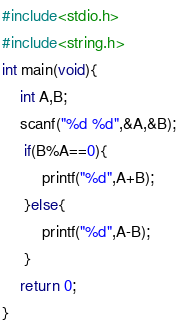<code> <loc_0><loc_0><loc_500><loc_500><_C_>#include<stdio.h>
#include<string.h>
int main(void){
    int A,B;
    scanf("%d %d",&A,&B);
     if(B%A==0){
         printf("%d",A+B);
     }else{
         printf("%d",A-B);
     }
    return 0;
}</code> 